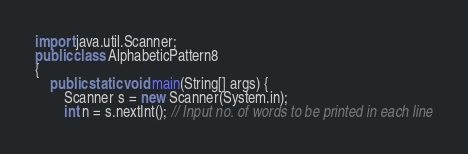Convert code to text. <code><loc_0><loc_0><loc_500><loc_500><_Java_>import java.util.Scanner;
public class AlphabeticPattern8
{
    public static void main(String[] args) {
        Scanner s = new Scanner(System.in);
        int n = s.nextInt(); // Input no. of words to be printed in each line</code> 